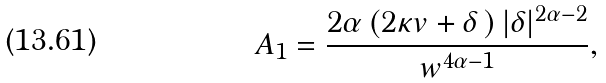<formula> <loc_0><loc_0><loc_500><loc_500>A _ { 1 } = \frac { 2 \alpha \left ( 2 \kappa v + \delta \, \right ) | \delta | ^ { 2 \alpha - 2 } } { w ^ { 4 \alpha - 1 } } ,</formula> 